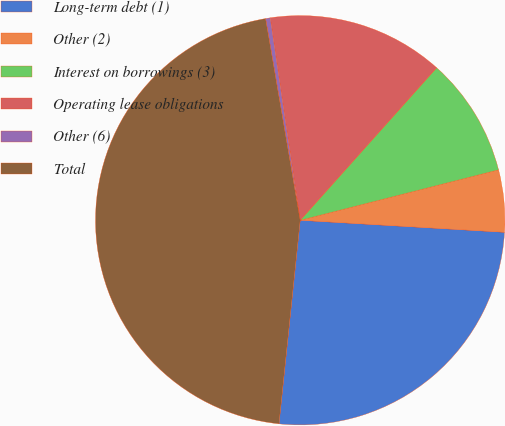Convert chart. <chart><loc_0><loc_0><loc_500><loc_500><pie_chart><fcel>Long-term debt (1)<fcel>Other (2)<fcel>Interest on borrowings (3)<fcel>Operating lease obligations<fcel>Other (6)<fcel>Total<nl><fcel>25.72%<fcel>4.9%<fcel>9.42%<fcel>13.95%<fcel>0.37%<fcel>45.64%<nl></chart> 